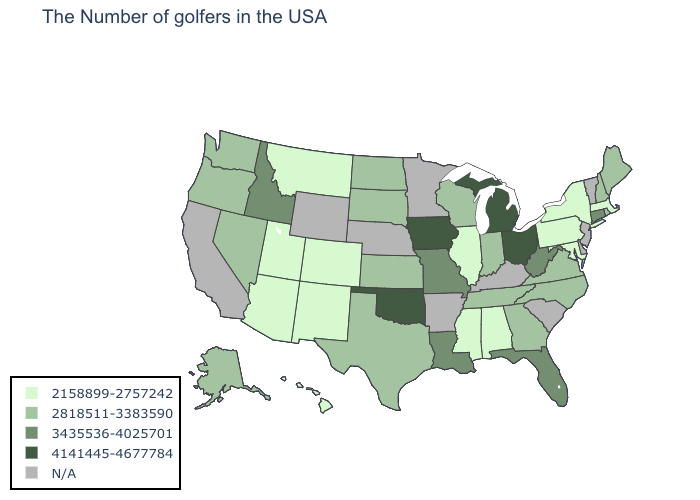Among the states that border Mississippi , which have the lowest value?
Short answer required. Alabama. What is the lowest value in the West?
Give a very brief answer. 2158899-2757242. Does the map have missing data?
Write a very short answer. Yes. What is the value of Missouri?
Short answer required. 3435536-4025701. Does the first symbol in the legend represent the smallest category?
Quick response, please. Yes. Name the states that have a value in the range 2818511-3383590?
Short answer required. Maine, Rhode Island, New Hampshire, Virginia, North Carolina, Georgia, Indiana, Tennessee, Wisconsin, Kansas, Texas, South Dakota, North Dakota, Nevada, Washington, Oregon, Alaska. Among the states that border Oklahoma , which have the lowest value?
Keep it brief. Colorado, New Mexico. Which states have the lowest value in the USA?
Concise answer only. Massachusetts, New York, Maryland, Pennsylvania, Alabama, Illinois, Mississippi, Colorado, New Mexico, Utah, Montana, Arizona, Hawaii. Does Idaho have the highest value in the West?
Short answer required. Yes. What is the lowest value in the Northeast?
Give a very brief answer. 2158899-2757242. Does Hawaii have the highest value in the USA?
Answer briefly. No. Which states have the lowest value in the USA?
Concise answer only. Massachusetts, New York, Maryland, Pennsylvania, Alabama, Illinois, Mississippi, Colorado, New Mexico, Utah, Montana, Arizona, Hawaii. What is the highest value in the USA?
Give a very brief answer. 4141445-4677784. What is the lowest value in the Northeast?
Write a very short answer. 2158899-2757242. 